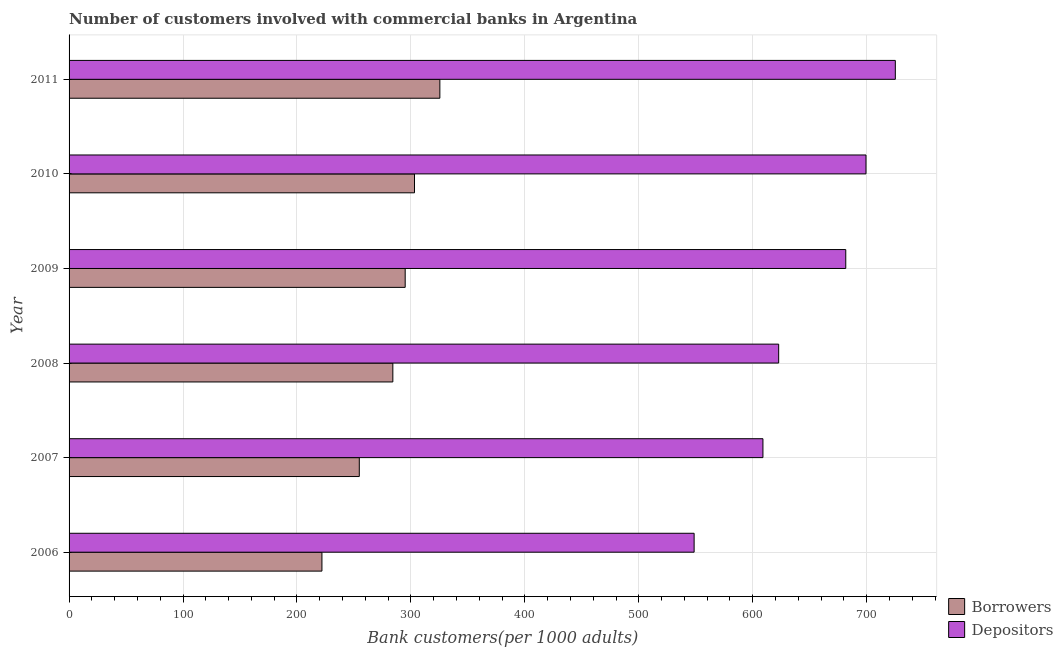Are the number of bars on each tick of the Y-axis equal?
Ensure brevity in your answer.  Yes. How many bars are there on the 4th tick from the top?
Your answer should be compact. 2. What is the label of the 2nd group of bars from the top?
Offer a terse response. 2010. In how many cases, is the number of bars for a given year not equal to the number of legend labels?
Ensure brevity in your answer.  0. What is the number of depositors in 2009?
Keep it short and to the point. 681.62. Across all years, what is the maximum number of borrowers?
Offer a terse response. 325.39. Across all years, what is the minimum number of borrowers?
Your answer should be very brief. 221.91. In which year was the number of depositors minimum?
Provide a succinct answer. 2006. What is the total number of borrowers in the graph?
Provide a short and direct response. 1684.25. What is the difference between the number of depositors in 2008 and that in 2011?
Provide a short and direct response. -102.37. What is the difference between the number of borrowers in 2009 and the number of depositors in 2011?
Offer a very short reply. -430.13. What is the average number of depositors per year?
Provide a succinct answer. 647.71. In the year 2008, what is the difference between the number of depositors and number of borrowers?
Keep it short and to the point. 338.6. In how many years, is the number of borrowers greater than 340 ?
Offer a very short reply. 0. What is the ratio of the number of borrowers in 2006 to that in 2011?
Provide a short and direct response. 0.68. Is the difference between the number of borrowers in 2008 and 2010 greater than the difference between the number of depositors in 2008 and 2010?
Offer a terse response. Yes. What is the difference between the highest and the second highest number of borrowers?
Your answer should be very brief. 22.25. What is the difference between the highest and the lowest number of depositors?
Your answer should be compact. 176.57. What does the 1st bar from the top in 2007 represents?
Give a very brief answer. Depositors. What does the 2nd bar from the bottom in 2010 represents?
Ensure brevity in your answer.  Depositors. How many bars are there?
Provide a short and direct response. 12. What is the difference between two consecutive major ticks on the X-axis?
Provide a succinct answer. 100. Does the graph contain any zero values?
Your answer should be very brief. No. Does the graph contain grids?
Provide a short and direct response. Yes. What is the title of the graph?
Your response must be concise. Number of customers involved with commercial banks in Argentina. What is the label or title of the X-axis?
Provide a short and direct response. Bank customers(per 1000 adults). What is the label or title of the Y-axis?
Make the answer very short. Year. What is the Bank customers(per 1000 adults) in Borrowers in 2006?
Your response must be concise. 221.91. What is the Bank customers(per 1000 adults) in Depositors in 2006?
Provide a short and direct response. 548.53. What is the Bank customers(per 1000 adults) of Borrowers in 2007?
Provide a short and direct response. 254.69. What is the Bank customers(per 1000 adults) in Depositors in 2007?
Offer a terse response. 608.93. What is the Bank customers(per 1000 adults) of Borrowers in 2008?
Your response must be concise. 284.14. What is the Bank customers(per 1000 adults) in Depositors in 2008?
Your answer should be very brief. 622.73. What is the Bank customers(per 1000 adults) of Borrowers in 2009?
Give a very brief answer. 294.97. What is the Bank customers(per 1000 adults) of Depositors in 2009?
Keep it short and to the point. 681.62. What is the Bank customers(per 1000 adults) in Borrowers in 2010?
Keep it short and to the point. 303.14. What is the Bank customers(per 1000 adults) in Depositors in 2010?
Your answer should be very brief. 699.37. What is the Bank customers(per 1000 adults) of Borrowers in 2011?
Give a very brief answer. 325.39. What is the Bank customers(per 1000 adults) in Depositors in 2011?
Provide a short and direct response. 725.1. Across all years, what is the maximum Bank customers(per 1000 adults) in Borrowers?
Ensure brevity in your answer.  325.39. Across all years, what is the maximum Bank customers(per 1000 adults) of Depositors?
Provide a short and direct response. 725.1. Across all years, what is the minimum Bank customers(per 1000 adults) in Borrowers?
Your answer should be very brief. 221.91. Across all years, what is the minimum Bank customers(per 1000 adults) in Depositors?
Make the answer very short. 548.53. What is the total Bank customers(per 1000 adults) of Borrowers in the graph?
Your response must be concise. 1684.25. What is the total Bank customers(per 1000 adults) of Depositors in the graph?
Your answer should be compact. 3886.28. What is the difference between the Bank customers(per 1000 adults) in Borrowers in 2006 and that in 2007?
Keep it short and to the point. -32.78. What is the difference between the Bank customers(per 1000 adults) of Depositors in 2006 and that in 2007?
Ensure brevity in your answer.  -60.4. What is the difference between the Bank customers(per 1000 adults) of Borrowers in 2006 and that in 2008?
Ensure brevity in your answer.  -62.22. What is the difference between the Bank customers(per 1000 adults) of Depositors in 2006 and that in 2008?
Your answer should be very brief. -74.2. What is the difference between the Bank customers(per 1000 adults) of Borrowers in 2006 and that in 2009?
Make the answer very short. -73.06. What is the difference between the Bank customers(per 1000 adults) of Depositors in 2006 and that in 2009?
Provide a succinct answer. -133.09. What is the difference between the Bank customers(per 1000 adults) of Borrowers in 2006 and that in 2010?
Your answer should be compact. -81.23. What is the difference between the Bank customers(per 1000 adults) in Depositors in 2006 and that in 2010?
Your answer should be compact. -150.84. What is the difference between the Bank customers(per 1000 adults) in Borrowers in 2006 and that in 2011?
Your answer should be compact. -103.48. What is the difference between the Bank customers(per 1000 adults) of Depositors in 2006 and that in 2011?
Offer a very short reply. -176.57. What is the difference between the Bank customers(per 1000 adults) in Borrowers in 2007 and that in 2008?
Ensure brevity in your answer.  -29.45. What is the difference between the Bank customers(per 1000 adults) of Depositors in 2007 and that in 2008?
Offer a terse response. -13.81. What is the difference between the Bank customers(per 1000 adults) in Borrowers in 2007 and that in 2009?
Your answer should be very brief. -40.28. What is the difference between the Bank customers(per 1000 adults) of Depositors in 2007 and that in 2009?
Your answer should be very brief. -72.69. What is the difference between the Bank customers(per 1000 adults) in Borrowers in 2007 and that in 2010?
Provide a short and direct response. -48.45. What is the difference between the Bank customers(per 1000 adults) in Depositors in 2007 and that in 2010?
Provide a short and direct response. -90.44. What is the difference between the Bank customers(per 1000 adults) in Borrowers in 2007 and that in 2011?
Provide a short and direct response. -70.7. What is the difference between the Bank customers(per 1000 adults) in Depositors in 2007 and that in 2011?
Offer a very short reply. -116.18. What is the difference between the Bank customers(per 1000 adults) of Borrowers in 2008 and that in 2009?
Provide a succinct answer. -10.83. What is the difference between the Bank customers(per 1000 adults) of Depositors in 2008 and that in 2009?
Your response must be concise. -58.89. What is the difference between the Bank customers(per 1000 adults) of Borrowers in 2008 and that in 2010?
Provide a short and direct response. -19.01. What is the difference between the Bank customers(per 1000 adults) of Depositors in 2008 and that in 2010?
Provide a succinct answer. -76.64. What is the difference between the Bank customers(per 1000 adults) of Borrowers in 2008 and that in 2011?
Provide a succinct answer. -41.25. What is the difference between the Bank customers(per 1000 adults) of Depositors in 2008 and that in 2011?
Provide a short and direct response. -102.37. What is the difference between the Bank customers(per 1000 adults) of Borrowers in 2009 and that in 2010?
Provide a succinct answer. -8.17. What is the difference between the Bank customers(per 1000 adults) of Depositors in 2009 and that in 2010?
Offer a very short reply. -17.75. What is the difference between the Bank customers(per 1000 adults) of Borrowers in 2009 and that in 2011?
Offer a very short reply. -30.42. What is the difference between the Bank customers(per 1000 adults) in Depositors in 2009 and that in 2011?
Give a very brief answer. -43.48. What is the difference between the Bank customers(per 1000 adults) of Borrowers in 2010 and that in 2011?
Offer a terse response. -22.25. What is the difference between the Bank customers(per 1000 adults) of Depositors in 2010 and that in 2011?
Keep it short and to the point. -25.73. What is the difference between the Bank customers(per 1000 adults) of Borrowers in 2006 and the Bank customers(per 1000 adults) of Depositors in 2007?
Ensure brevity in your answer.  -387.01. What is the difference between the Bank customers(per 1000 adults) of Borrowers in 2006 and the Bank customers(per 1000 adults) of Depositors in 2008?
Offer a terse response. -400.82. What is the difference between the Bank customers(per 1000 adults) of Borrowers in 2006 and the Bank customers(per 1000 adults) of Depositors in 2009?
Provide a succinct answer. -459.7. What is the difference between the Bank customers(per 1000 adults) of Borrowers in 2006 and the Bank customers(per 1000 adults) of Depositors in 2010?
Offer a very short reply. -477.46. What is the difference between the Bank customers(per 1000 adults) in Borrowers in 2006 and the Bank customers(per 1000 adults) in Depositors in 2011?
Provide a short and direct response. -503.19. What is the difference between the Bank customers(per 1000 adults) in Borrowers in 2007 and the Bank customers(per 1000 adults) in Depositors in 2008?
Provide a succinct answer. -368.04. What is the difference between the Bank customers(per 1000 adults) in Borrowers in 2007 and the Bank customers(per 1000 adults) in Depositors in 2009?
Make the answer very short. -426.93. What is the difference between the Bank customers(per 1000 adults) in Borrowers in 2007 and the Bank customers(per 1000 adults) in Depositors in 2010?
Provide a succinct answer. -444.68. What is the difference between the Bank customers(per 1000 adults) of Borrowers in 2007 and the Bank customers(per 1000 adults) of Depositors in 2011?
Offer a very short reply. -470.41. What is the difference between the Bank customers(per 1000 adults) in Borrowers in 2008 and the Bank customers(per 1000 adults) in Depositors in 2009?
Keep it short and to the point. -397.48. What is the difference between the Bank customers(per 1000 adults) in Borrowers in 2008 and the Bank customers(per 1000 adults) in Depositors in 2010?
Provide a succinct answer. -415.23. What is the difference between the Bank customers(per 1000 adults) in Borrowers in 2008 and the Bank customers(per 1000 adults) in Depositors in 2011?
Offer a terse response. -440.97. What is the difference between the Bank customers(per 1000 adults) of Borrowers in 2009 and the Bank customers(per 1000 adults) of Depositors in 2010?
Give a very brief answer. -404.4. What is the difference between the Bank customers(per 1000 adults) in Borrowers in 2009 and the Bank customers(per 1000 adults) in Depositors in 2011?
Ensure brevity in your answer.  -430.13. What is the difference between the Bank customers(per 1000 adults) in Borrowers in 2010 and the Bank customers(per 1000 adults) in Depositors in 2011?
Ensure brevity in your answer.  -421.96. What is the average Bank customers(per 1000 adults) of Borrowers per year?
Keep it short and to the point. 280.71. What is the average Bank customers(per 1000 adults) of Depositors per year?
Your answer should be very brief. 647.71. In the year 2006, what is the difference between the Bank customers(per 1000 adults) in Borrowers and Bank customers(per 1000 adults) in Depositors?
Keep it short and to the point. -326.62. In the year 2007, what is the difference between the Bank customers(per 1000 adults) of Borrowers and Bank customers(per 1000 adults) of Depositors?
Make the answer very short. -354.23. In the year 2008, what is the difference between the Bank customers(per 1000 adults) of Borrowers and Bank customers(per 1000 adults) of Depositors?
Make the answer very short. -338.6. In the year 2009, what is the difference between the Bank customers(per 1000 adults) of Borrowers and Bank customers(per 1000 adults) of Depositors?
Offer a very short reply. -386.65. In the year 2010, what is the difference between the Bank customers(per 1000 adults) of Borrowers and Bank customers(per 1000 adults) of Depositors?
Offer a terse response. -396.23. In the year 2011, what is the difference between the Bank customers(per 1000 adults) in Borrowers and Bank customers(per 1000 adults) in Depositors?
Keep it short and to the point. -399.71. What is the ratio of the Bank customers(per 1000 adults) in Borrowers in 2006 to that in 2007?
Keep it short and to the point. 0.87. What is the ratio of the Bank customers(per 1000 adults) of Depositors in 2006 to that in 2007?
Give a very brief answer. 0.9. What is the ratio of the Bank customers(per 1000 adults) in Borrowers in 2006 to that in 2008?
Your answer should be compact. 0.78. What is the ratio of the Bank customers(per 1000 adults) of Depositors in 2006 to that in 2008?
Your answer should be very brief. 0.88. What is the ratio of the Bank customers(per 1000 adults) of Borrowers in 2006 to that in 2009?
Provide a short and direct response. 0.75. What is the ratio of the Bank customers(per 1000 adults) in Depositors in 2006 to that in 2009?
Your response must be concise. 0.8. What is the ratio of the Bank customers(per 1000 adults) of Borrowers in 2006 to that in 2010?
Your answer should be very brief. 0.73. What is the ratio of the Bank customers(per 1000 adults) of Depositors in 2006 to that in 2010?
Your answer should be compact. 0.78. What is the ratio of the Bank customers(per 1000 adults) of Borrowers in 2006 to that in 2011?
Make the answer very short. 0.68. What is the ratio of the Bank customers(per 1000 adults) in Depositors in 2006 to that in 2011?
Give a very brief answer. 0.76. What is the ratio of the Bank customers(per 1000 adults) in Borrowers in 2007 to that in 2008?
Ensure brevity in your answer.  0.9. What is the ratio of the Bank customers(per 1000 adults) in Depositors in 2007 to that in 2008?
Your answer should be very brief. 0.98. What is the ratio of the Bank customers(per 1000 adults) in Borrowers in 2007 to that in 2009?
Keep it short and to the point. 0.86. What is the ratio of the Bank customers(per 1000 adults) of Depositors in 2007 to that in 2009?
Provide a succinct answer. 0.89. What is the ratio of the Bank customers(per 1000 adults) in Borrowers in 2007 to that in 2010?
Your response must be concise. 0.84. What is the ratio of the Bank customers(per 1000 adults) in Depositors in 2007 to that in 2010?
Provide a succinct answer. 0.87. What is the ratio of the Bank customers(per 1000 adults) in Borrowers in 2007 to that in 2011?
Make the answer very short. 0.78. What is the ratio of the Bank customers(per 1000 adults) in Depositors in 2007 to that in 2011?
Your response must be concise. 0.84. What is the ratio of the Bank customers(per 1000 adults) in Borrowers in 2008 to that in 2009?
Give a very brief answer. 0.96. What is the ratio of the Bank customers(per 1000 adults) in Depositors in 2008 to that in 2009?
Your response must be concise. 0.91. What is the ratio of the Bank customers(per 1000 adults) in Borrowers in 2008 to that in 2010?
Offer a very short reply. 0.94. What is the ratio of the Bank customers(per 1000 adults) in Depositors in 2008 to that in 2010?
Keep it short and to the point. 0.89. What is the ratio of the Bank customers(per 1000 adults) of Borrowers in 2008 to that in 2011?
Provide a succinct answer. 0.87. What is the ratio of the Bank customers(per 1000 adults) in Depositors in 2008 to that in 2011?
Your answer should be very brief. 0.86. What is the ratio of the Bank customers(per 1000 adults) in Borrowers in 2009 to that in 2010?
Give a very brief answer. 0.97. What is the ratio of the Bank customers(per 1000 adults) in Depositors in 2009 to that in 2010?
Your response must be concise. 0.97. What is the ratio of the Bank customers(per 1000 adults) of Borrowers in 2009 to that in 2011?
Your response must be concise. 0.91. What is the ratio of the Bank customers(per 1000 adults) of Borrowers in 2010 to that in 2011?
Your response must be concise. 0.93. What is the ratio of the Bank customers(per 1000 adults) of Depositors in 2010 to that in 2011?
Ensure brevity in your answer.  0.96. What is the difference between the highest and the second highest Bank customers(per 1000 adults) of Borrowers?
Your answer should be compact. 22.25. What is the difference between the highest and the second highest Bank customers(per 1000 adults) of Depositors?
Your response must be concise. 25.73. What is the difference between the highest and the lowest Bank customers(per 1000 adults) of Borrowers?
Provide a short and direct response. 103.48. What is the difference between the highest and the lowest Bank customers(per 1000 adults) in Depositors?
Offer a terse response. 176.57. 